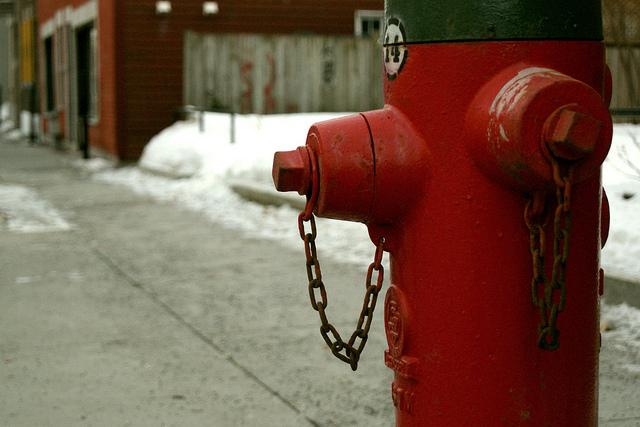What might happen as a consequence of someone not using this device as required by law?
Keep it brief. Arrest. How many chains are hanging from the fire hydrant?
Short answer required. 2. What color is the fire hydrant?
Write a very short answer. Red. Which department enforces the proper use of this item?
Quick response, please. Fire department. Can you determine if its cold?
Be succinct. Yes. 